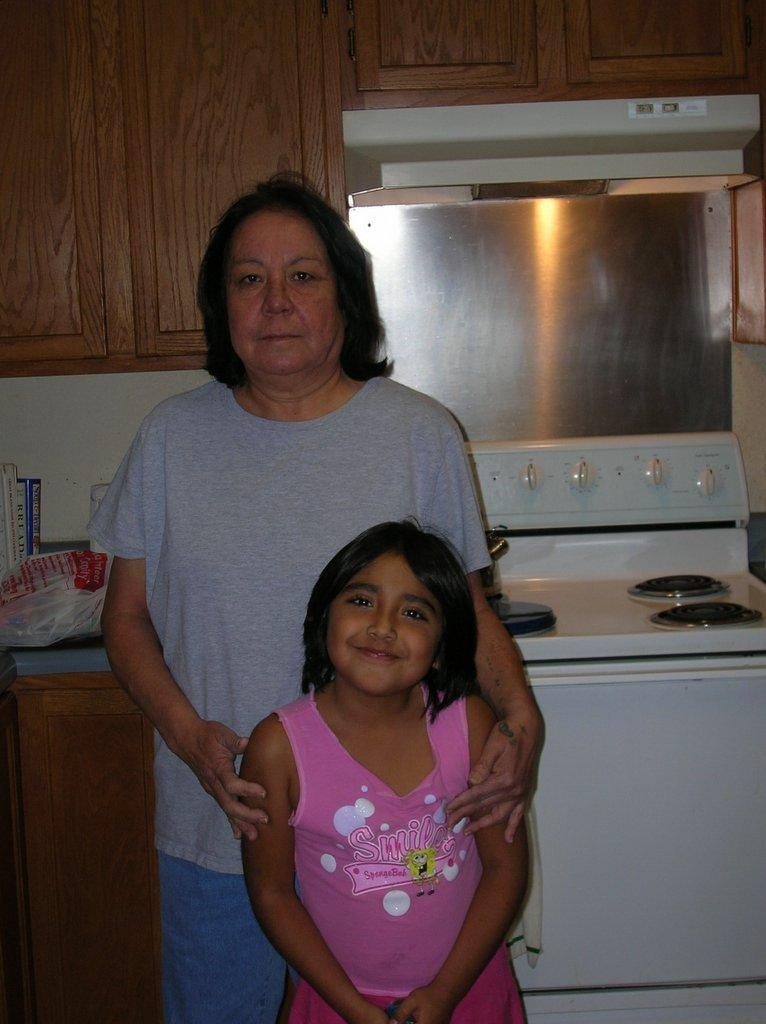<image>
Summarize the visual content of the image. A woman a girl are taking a picture in front of a book titled bread. 